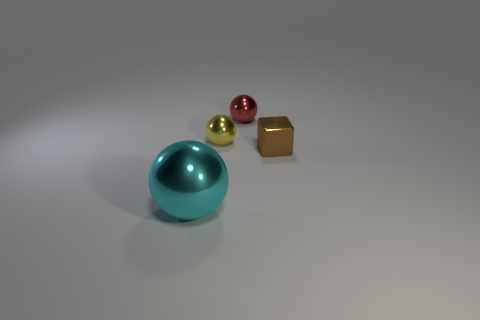Add 2 green balls. How many objects exist? 6 Subtract all balls. How many objects are left? 1 Add 1 blue things. How many blue things exist? 1 Subtract 0 cyan cylinders. How many objects are left? 4 Subtract all brown cubes. Subtract all large brown matte spheres. How many objects are left? 3 Add 3 tiny brown cubes. How many tiny brown cubes are left? 4 